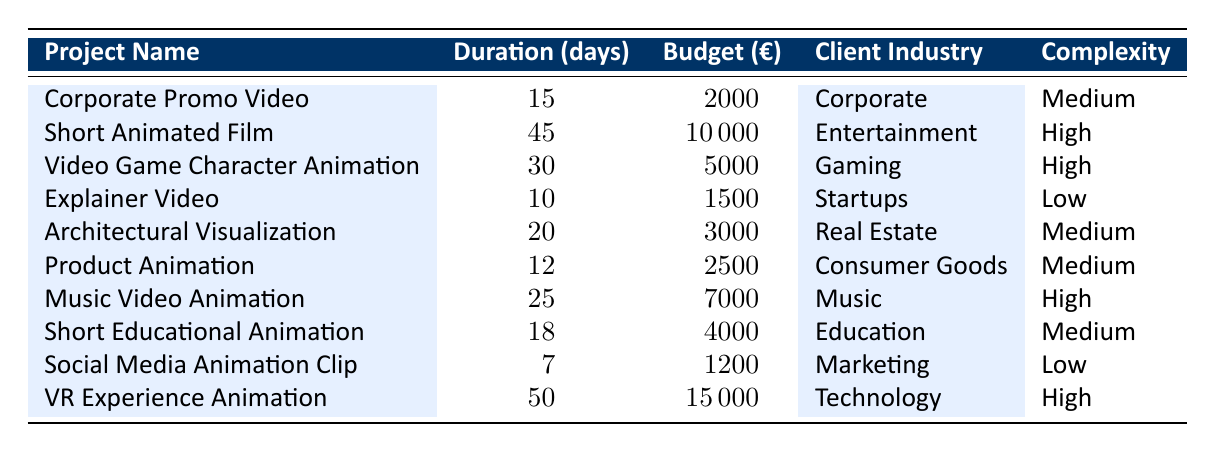What is the average duration for a Corporate Promo Video project? The table shows that the average duration for a Corporate Promo Video is 15 days.
Answer: 15 days Which project has the highest average budget? The VR Experience Animation has the highest average budget of €15,000 as seen in the table.
Answer: €15,000 Is the average budget for a Short Educational Animation project greater than €3,000? The average budget for a Short Educational Animation is €4,000, which is greater than €3,000.
Answer: Yes What is the total average duration of all projects listed in the table? The individual durations for the projects are added up as follows: 15 + 45 + 30 + 10 + 20 + 12 + 25 + 18 + 7 + 50 =  232 days. Therefore, the total average duration is 232 / 10 = 23.2 days.
Answer: 23.2 days Are there any projects in the table with a complexity level categorized as 'Low'? Yes, the 'Explainer Video' and 'Social Media Animation Clip' are categorized as 'Low' complexity.
Answer: Yes What is the average budget of all 'High' complexity projects? The budgets for High complexity projects are €10,000 (Short Animated Film), €5,000 (Video Game Character Animation), €7,000 (Music Video Animation), and €15,000 (VR Experience Animation). The total comes to €37,000 for 4 projects, so the average budget is €37,000 / 4 = €9,250.
Answer: €9,250 Which client industry has the shortest average duration among its projects? The shortest average duration listed is 7 days from the Marketing industry for the Social Media Animation Clip project.
Answer: Marketing (7 days) What is the average budget for projects in the Gaming industry? The only project listed in the Gaming industry is the Video Game Character Animation, which has an average budget of €5,000. Thus, the average is €5,000.
Answer: €5,000 How many projects listed in the table have an average duration of 20 days or more? The projects with a duration of 20 days or more are: Short Animated Film (45), Video Game Character Animation (30), Music Video Animation (25), VR Experience Animation (50). This gives us a total of 4 projects.
Answer: 4 projects 